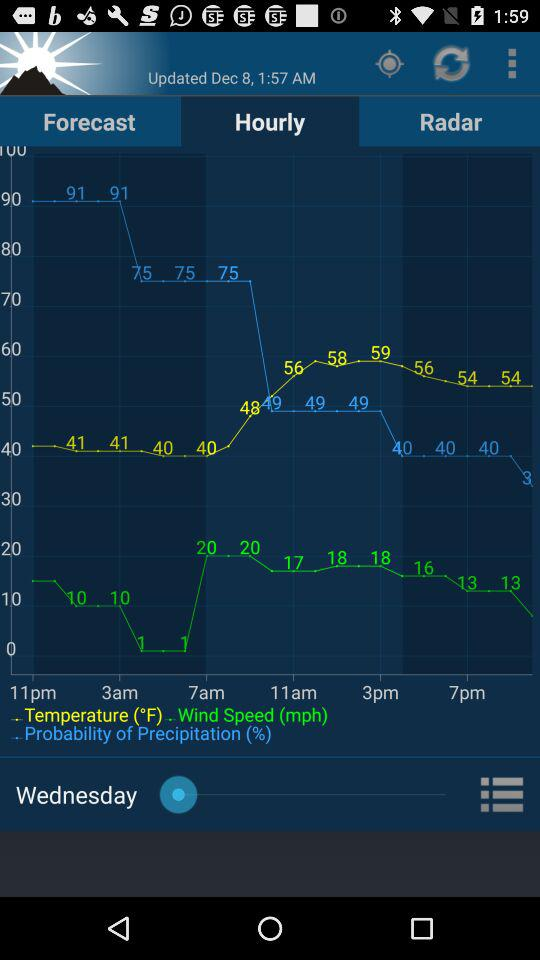What date and time was the content last updated? The content was last updated on December 8 at 1:57 a.m. 